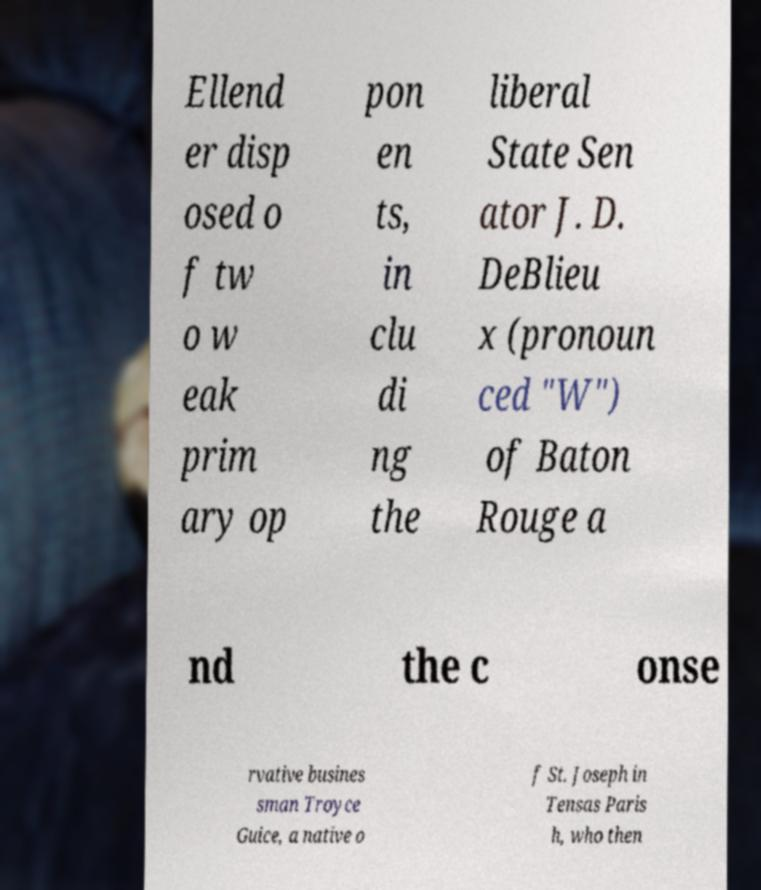Could you extract and type out the text from this image? Ellend er disp osed o f tw o w eak prim ary op pon en ts, in clu di ng the liberal State Sen ator J. D. DeBlieu x (pronoun ced "W") of Baton Rouge a nd the c onse rvative busines sman Troyce Guice, a native o f St. Joseph in Tensas Paris h, who then 